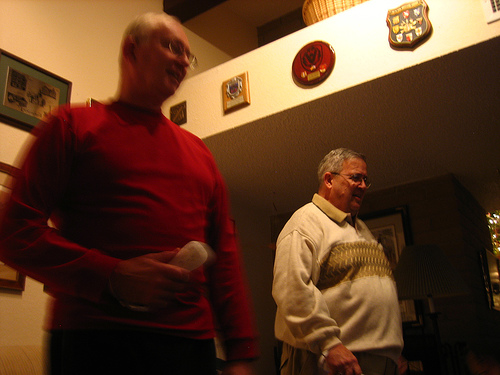Can you tell me what the event might be where this photo was taken? Based on the casual attire and indoor setting, it appears this could be a relaxed social gathering, possibly a family event or a small get-together among friends. 